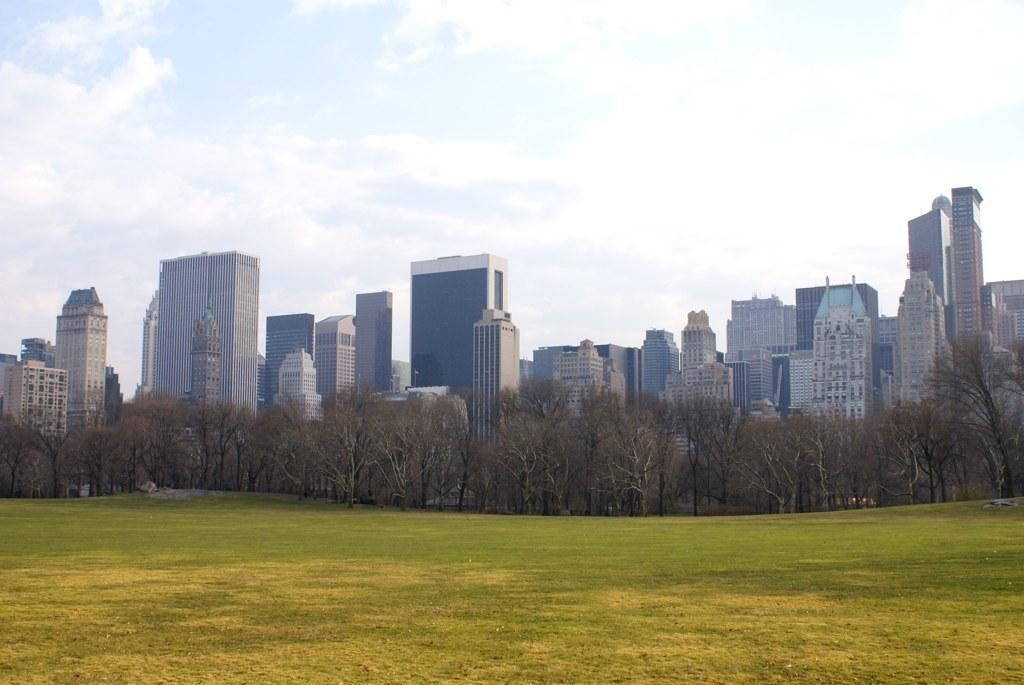What type of structures can be seen in the image? There are buildings in the image. What other natural elements are present in the image? There are trees in the image. What part of the sky is visible in the image? The sky is visible in the image, and clouds are present. What is visible at the bottom of the image? The ground is visible at the bottom of the image. What type of sand can be seen on the donkey's back? There is no donkey present in the image, and therefore no sand on its back. 